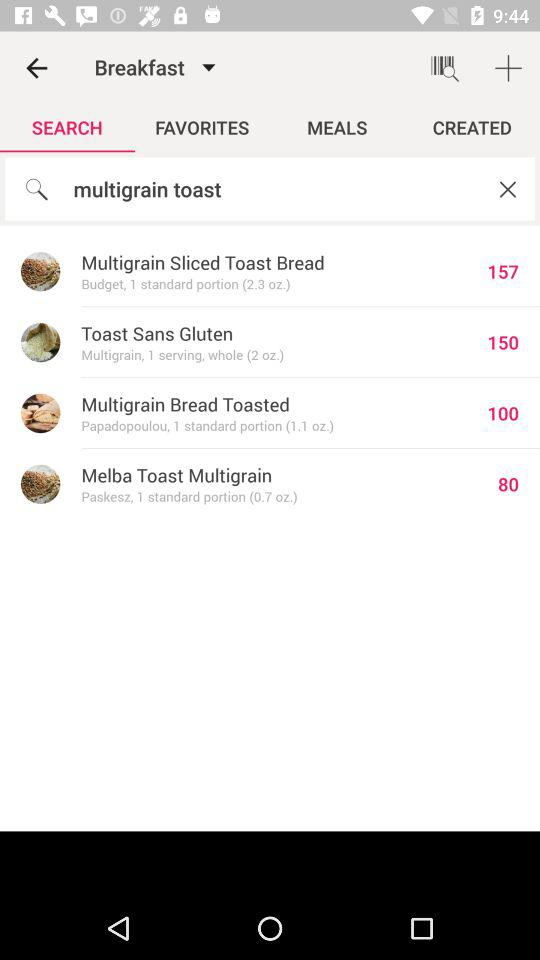How many more calories are in the Melba Toast Multigrain than the Toast Sans Gluten?
Answer the question using a single word or phrase. 70 